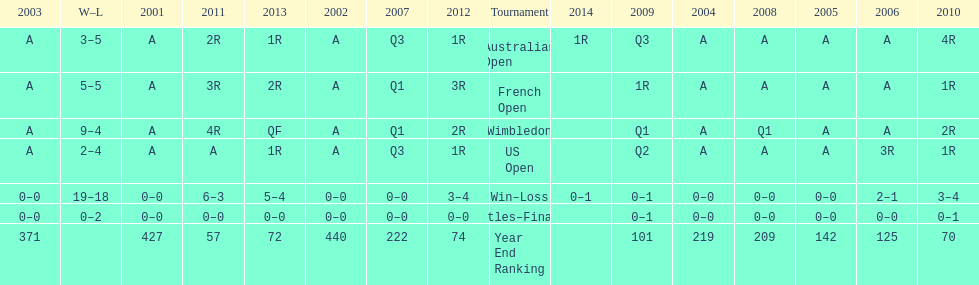Which years was a ranking below 200 achieved? 2005, 2006, 2009, 2010, 2011, 2012, 2013. 